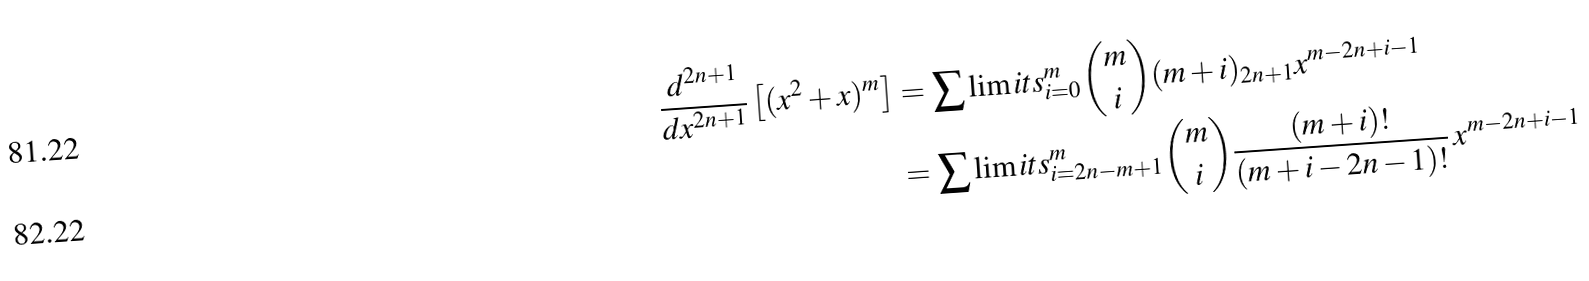Convert formula to latex. <formula><loc_0><loc_0><loc_500><loc_500>\frac { d ^ { 2 n + 1 } } { d x ^ { 2 n + 1 } } \left [ ( x ^ { 2 } + x ) ^ { m } \right ] & = \sum \lim i t s _ { i = 0 } ^ { m } { m \choose i } ( m + i ) _ { 2 n + 1 } x ^ { m - 2 n + i - 1 } \\ & = \sum \lim i t s _ { i = 2 n - m + 1 } ^ { m } { m \choose i } \frac { ( m + i ) ! } { ( m + i - 2 n - 1 ) ! } \, x ^ { m - 2 n + i - 1 }</formula> 